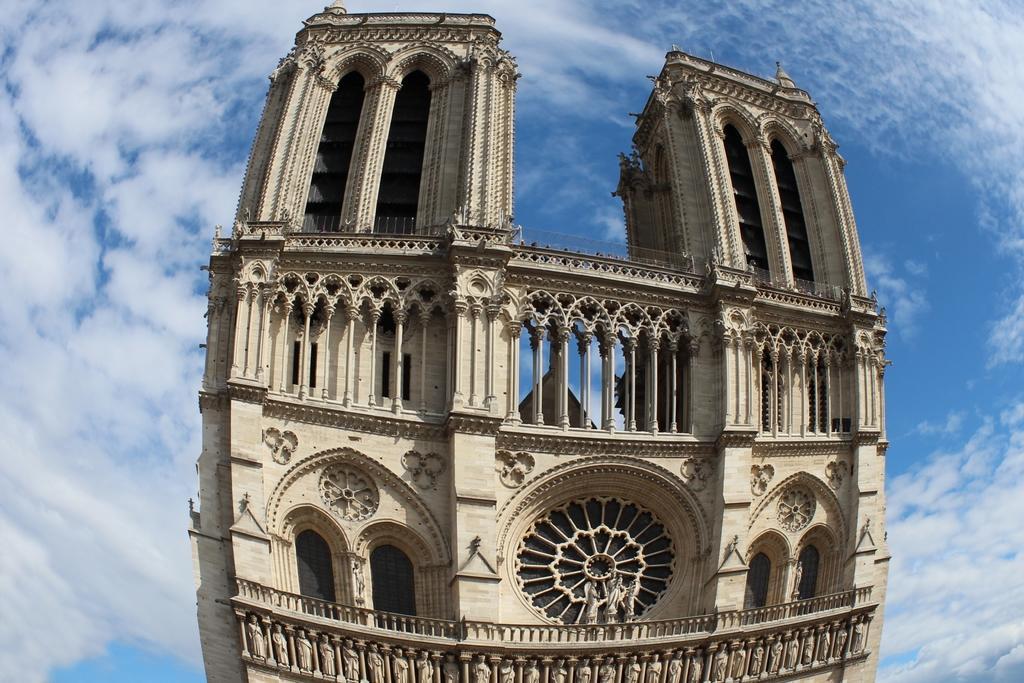Please provide a concise description of this image. In this image there is a building. There are sculptures on the building. In the background there is the sky. There are clouds in the sky. 